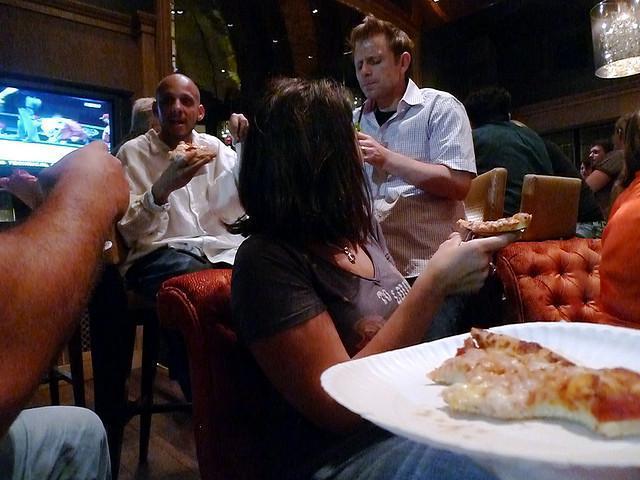How many people are there?
Give a very brief answer. 6. How many chairs are in the picture?
Give a very brief answer. 3. 